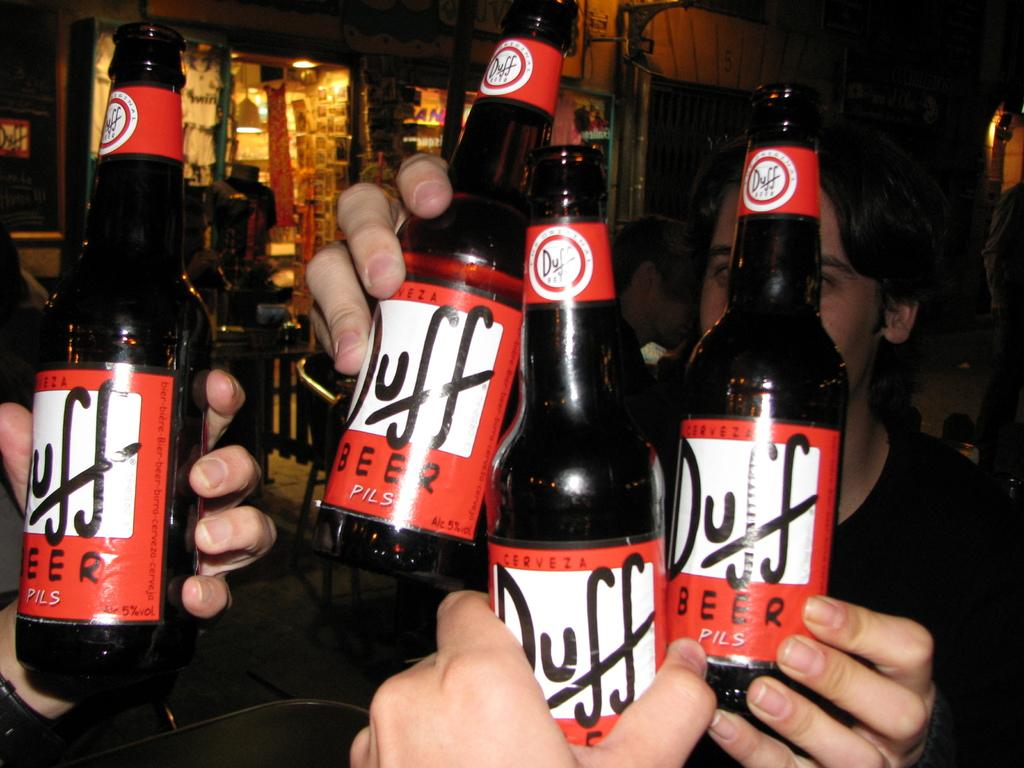Provide a one-sentence caption for the provided image. four people holding up bottles of duff beer. 